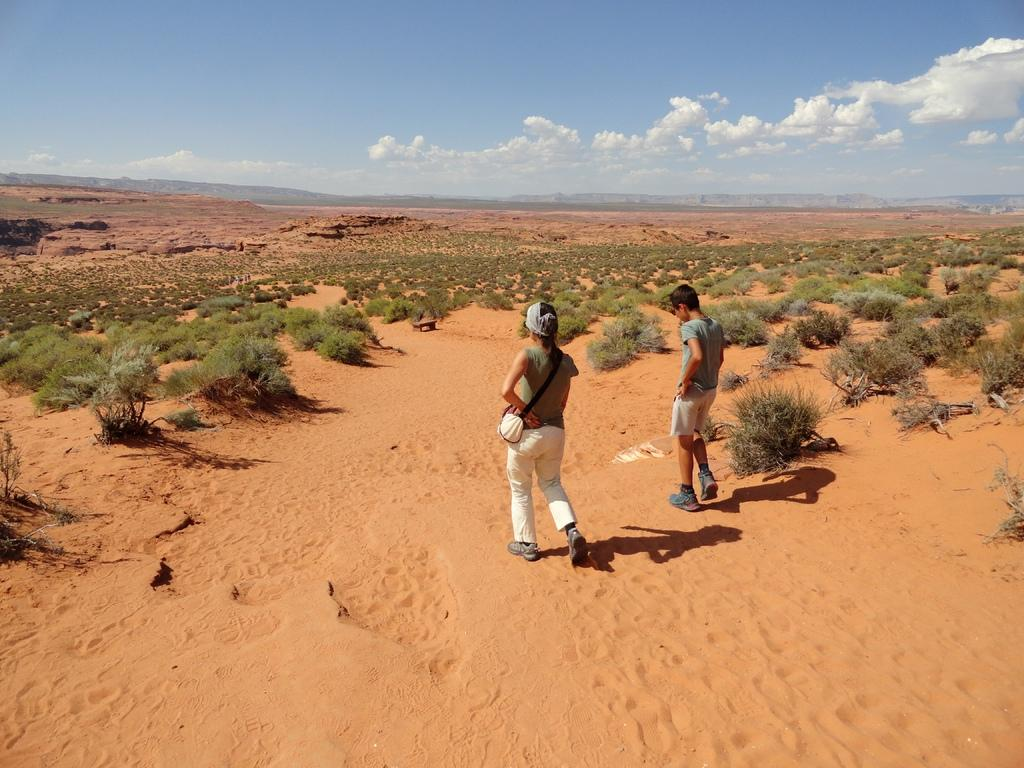What are the two persons in the image doing? The two persons in the image are walking on the sand. What are the persons wearing? The persons are wearing t-shirts. What can be seen on the sand besides the persons? There are trees on the sand. What is visible at the top of the image? The sky is visible at the top of the image. Can you tell me how many waves are crashing on the shore in the image? There are no waves visible in the image; it shows two persons walking on the sand with trees nearby. What type of quill is being used by the person in the image? There is no person using a quill in the image; it features two persons walking on the sand and trees on the sand. 